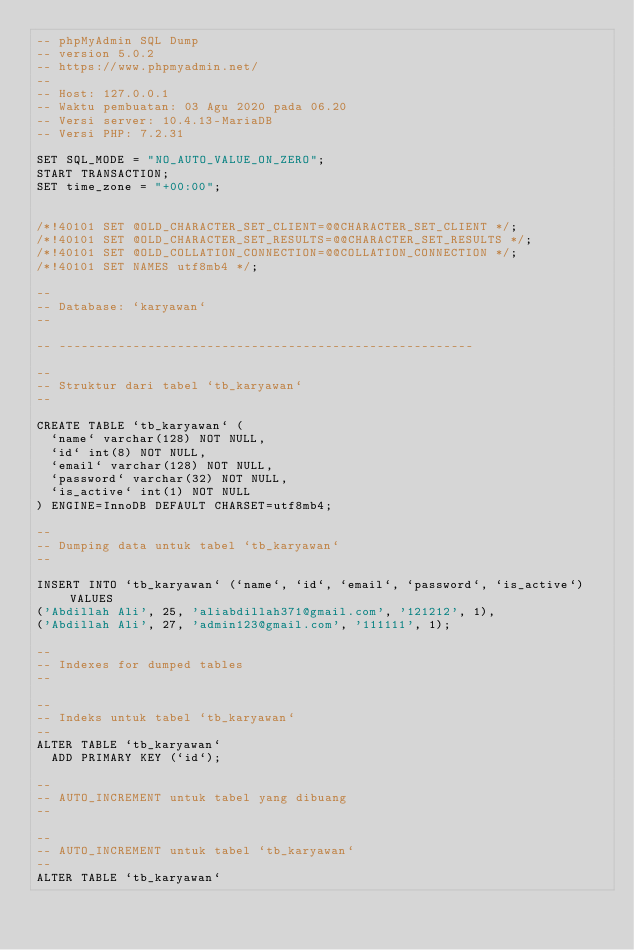Convert code to text. <code><loc_0><loc_0><loc_500><loc_500><_SQL_>-- phpMyAdmin SQL Dump
-- version 5.0.2
-- https://www.phpmyadmin.net/
--
-- Host: 127.0.0.1
-- Waktu pembuatan: 03 Agu 2020 pada 06.20
-- Versi server: 10.4.13-MariaDB
-- Versi PHP: 7.2.31

SET SQL_MODE = "NO_AUTO_VALUE_ON_ZERO";
START TRANSACTION;
SET time_zone = "+00:00";


/*!40101 SET @OLD_CHARACTER_SET_CLIENT=@@CHARACTER_SET_CLIENT */;
/*!40101 SET @OLD_CHARACTER_SET_RESULTS=@@CHARACTER_SET_RESULTS */;
/*!40101 SET @OLD_COLLATION_CONNECTION=@@COLLATION_CONNECTION */;
/*!40101 SET NAMES utf8mb4 */;

--
-- Database: `karyawan`
--

-- --------------------------------------------------------

--
-- Struktur dari tabel `tb_karyawan`
--

CREATE TABLE `tb_karyawan` (
  `name` varchar(128) NOT NULL,
  `id` int(8) NOT NULL,
  `email` varchar(128) NOT NULL,
  `password` varchar(32) NOT NULL,
  `is_active` int(1) NOT NULL
) ENGINE=InnoDB DEFAULT CHARSET=utf8mb4;

--
-- Dumping data untuk tabel `tb_karyawan`
--

INSERT INTO `tb_karyawan` (`name`, `id`, `email`, `password`, `is_active`) VALUES
('Abdillah Ali', 25, 'aliabdillah371@gmail.com', '121212', 1),
('Abdillah Ali', 27, 'admin123@gmail.com', '111111', 1);

--
-- Indexes for dumped tables
--

--
-- Indeks untuk tabel `tb_karyawan`
--
ALTER TABLE `tb_karyawan`
  ADD PRIMARY KEY (`id`);

--
-- AUTO_INCREMENT untuk tabel yang dibuang
--

--
-- AUTO_INCREMENT untuk tabel `tb_karyawan`
--
ALTER TABLE `tb_karyawan`</code> 